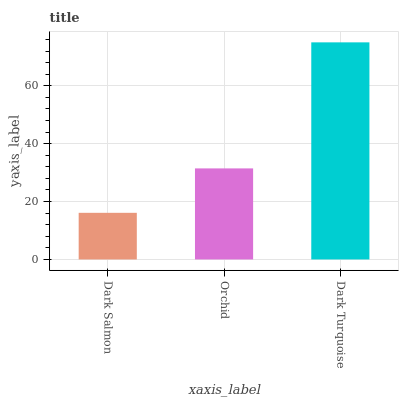Is Dark Salmon the minimum?
Answer yes or no. Yes. Is Dark Turquoise the maximum?
Answer yes or no. Yes. Is Orchid the minimum?
Answer yes or no. No. Is Orchid the maximum?
Answer yes or no. No. Is Orchid greater than Dark Salmon?
Answer yes or no. Yes. Is Dark Salmon less than Orchid?
Answer yes or no. Yes. Is Dark Salmon greater than Orchid?
Answer yes or no. No. Is Orchid less than Dark Salmon?
Answer yes or no. No. Is Orchid the high median?
Answer yes or no. Yes. Is Orchid the low median?
Answer yes or no. Yes. Is Dark Salmon the high median?
Answer yes or no. No. Is Dark Turquoise the low median?
Answer yes or no. No. 